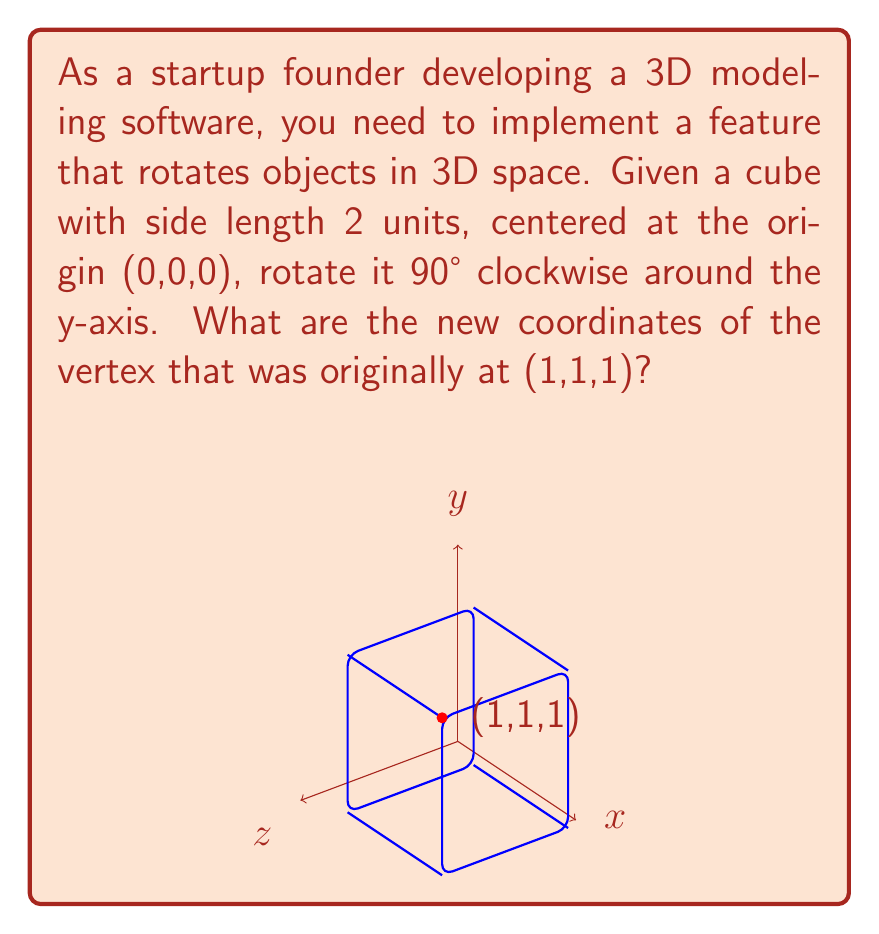Give your solution to this math problem. To solve this problem, we need to apply the rotation matrix for a 90° clockwise rotation around the y-axis. The steps are as follows:

1) The rotation matrix for a 90° clockwise rotation around the y-axis is:

   $$R_y(90°) = \begin{pmatrix}
   0 & 0 & 1 \\
   0 & 1 & 0 \\
   -1 & 0 & 0
   \end{pmatrix}$$

2) We need to multiply this matrix by the original coordinate vector:

   $$\begin{pmatrix}
   0 & 0 & 1 \\
   0 & 1 & 0 \\
   -1 & 0 & 0
   \end{pmatrix} \cdot \begin{pmatrix}
   1 \\
   1 \\
   1
   \end{pmatrix}$$

3) Performing the matrix multiplication:

   $$\begin{pmatrix}
   0(1) + 0(1) + 1(1) \\
   0(1) + 1(1) + 0(1) \\
   -1(1) + 0(1) + 0(1)
   \end{pmatrix} = \begin{pmatrix}
   1 \\
   1 \\
   -1
   \end{pmatrix}$$

4) Therefore, after the rotation, the new coordinates of the vertex are (1,1,-1).
Answer: (1,1,-1) 